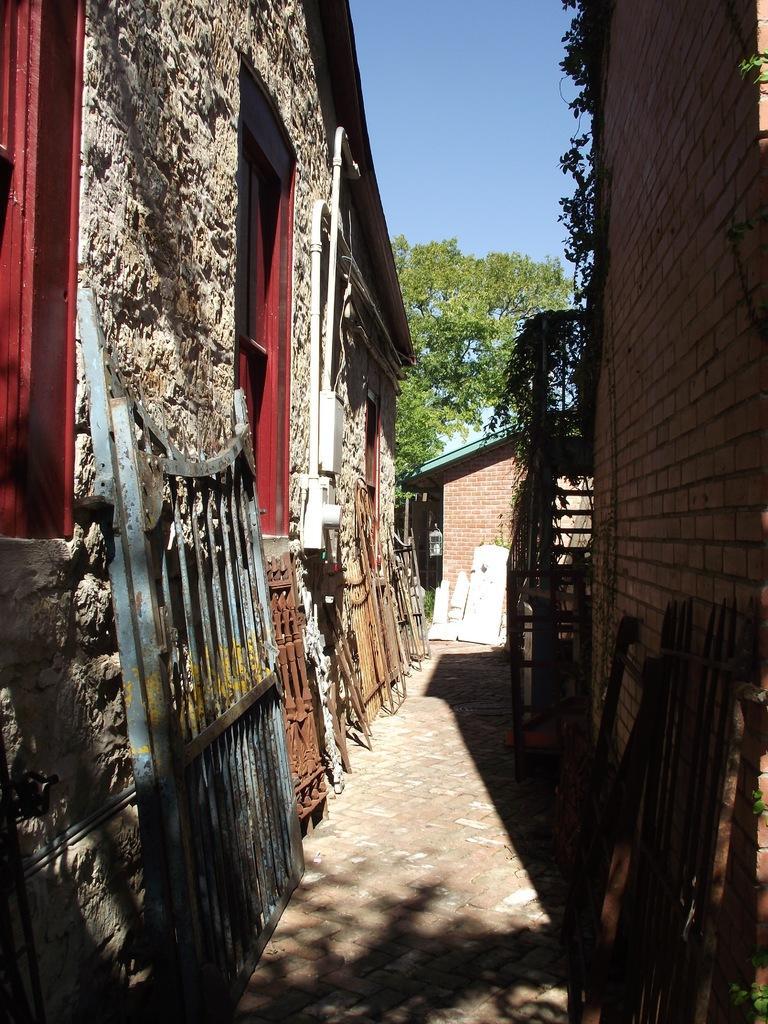Could you give a brief overview of what you see in this image? There are buildings on the either side and there are gates in the middle of the buildings. There are trees in front of them and the sky is blue in color. 